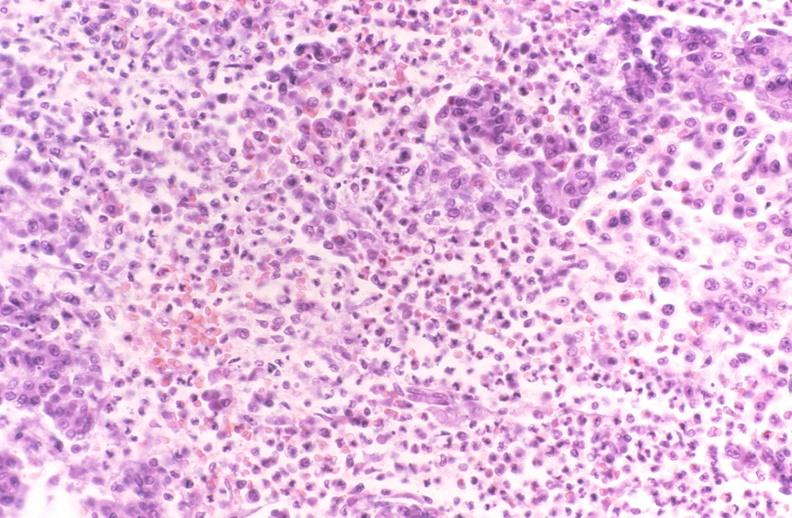does glioma show pancreatic fat necrosis, pancreatitis/necrosis?
Answer the question using a single word or phrase. No 